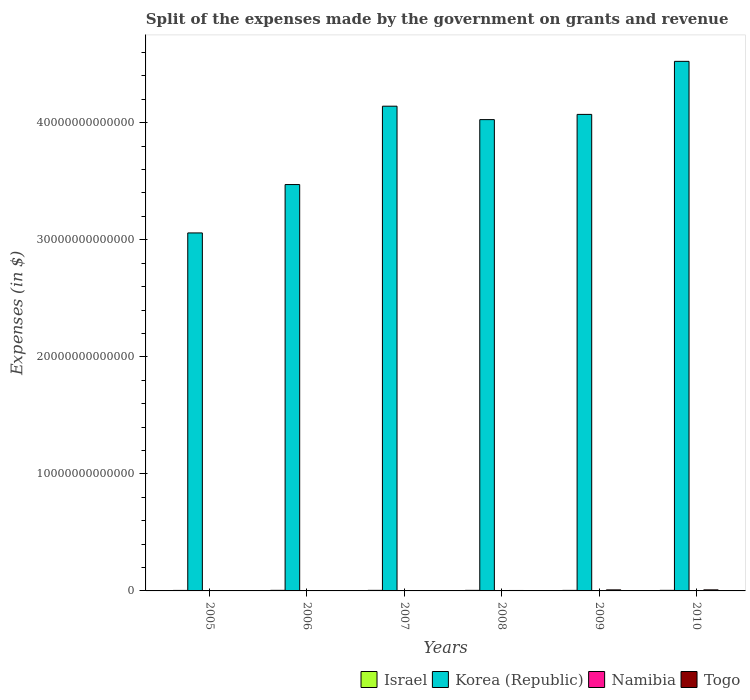How many different coloured bars are there?
Your answer should be compact. 4. Are the number of bars on each tick of the X-axis equal?
Give a very brief answer. Yes. How many bars are there on the 6th tick from the left?
Provide a succinct answer. 4. How many bars are there on the 1st tick from the right?
Your answer should be compact. 4. What is the label of the 1st group of bars from the left?
Provide a succinct answer. 2005. In how many cases, is the number of bars for a given year not equal to the number of legend labels?
Offer a terse response. 0. What is the expenses made by the government on grants and revenue in Korea (Republic) in 2007?
Your answer should be compact. 4.14e+13. Across all years, what is the maximum expenses made by the government on grants and revenue in Togo?
Provide a succinct answer. 8.96e+1. Across all years, what is the minimum expenses made by the government on grants and revenue in Namibia?
Keep it short and to the point. 1.10e+09. What is the total expenses made by the government on grants and revenue in Togo in the graph?
Offer a very short reply. 2.82e+11. What is the difference between the expenses made by the government on grants and revenue in Korea (Republic) in 2006 and that in 2007?
Provide a short and direct response. -6.70e+12. What is the difference between the expenses made by the government on grants and revenue in Namibia in 2010 and the expenses made by the government on grants and revenue in Korea (Republic) in 2009?
Offer a very short reply. -4.07e+13. What is the average expenses made by the government on grants and revenue in Israel per year?
Your response must be concise. 4.79e+1. In the year 2008, what is the difference between the expenses made by the government on grants and revenue in Togo and expenses made by the government on grants and revenue in Korea (Republic)?
Ensure brevity in your answer.  -4.02e+13. In how many years, is the expenses made by the government on grants and revenue in Korea (Republic) greater than 20000000000000 $?
Give a very brief answer. 6. What is the ratio of the expenses made by the government on grants and revenue in Korea (Republic) in 2008 to that in 2010?
Keep it short and to the point. 0.89. What is the difference between the highest and the second highest expenses made by the government on grants and revenue in Togo?
Provide a short and direct response. 6.60e+08. What is the difference between the highest and the lowest expenses made by the government on grants and revenue in Korea (Republic)?
Give a very brief answer. 1.47e+13. Is the sum of the expenses made by the government on grants and revenue in Togo in 2005 and 2006 greater than the maximum expenses made by the government on grants and revenue in Israel across all years?
Your response must be concise. No. Is it the case that in every year, the sum of the expenses made by the government on grants and revenue in Korea (Republic) and expenses made by the government on grants and revenue in Israel is greater than the sum of expenses made by the government on grants and revenue in Namibia and expenses made by the government on grants and revenue in Togo?
Offer a very short reply. No. What does the 1st bar from the right in 2010 represents?
Ensure brevity in your answer.  Togo. Are all the bars in the graph horizontal?
Provide a succinct answer. No. What is the difference between two consecutive major ticks on the Y-axis?
Ensure brevity in your answer.  1.00e+13. Does the graph contain any zero values?
Keep it short and to the point. No. Does the graph contain grids?
Your response must be concise. No. Where does the legend appear in the graph?
Ensure brevity in your answer.  Bottom right. How many legend labels are there?
Your answer should be compact. 4. What is the title of the graph?
Provide a succinct answer. Split of the expenses made by the government on grants and revenue. What is the label or title of the Y-axis?
Your answer should be compact. Expenses (in $). What is the Expenses (in $) of Israel in 2005?
Provide a succinct answer. 4.33e+1. What is the Expenses (in $) in Korea (Republic) in 2005?
Provide a short and direct response. 3.06e+13. What is the Expenses (in $) in Namibia in 2005?
Make the answer very short. 1.10e+09. What is the Expenses (in $) of Togo in 2005?
Give a very brief answer. 8.55e+09. What is the Expenses (in $) of Israel in 2006?
Your response must be concise. 5.00e+1. What is the Expenses (in $) of Korea (Republic) in 2006?
Keep it short and to the point. 3.47e+13. What is the Expenses (in $) in Namibia in 2006?
Give a very brief answer. 1.75e+09. What is the Expenses (in $) of Togo in 2006?
Provide a succinct answer. 2.87e+1. What is the Expenses (in $) in Israel in 2007?
Offer a terse response. 4.86e+1. What is the Expenses (in $) in Korea (Republic) in 2007?
Provide a succinct answer. 4.14e+13. What is the Expenses (in $) in Namibia in 2007?
Keep it short and to the point. 1.30e+09. What is the Expenses (in $) of Togo in 2007?
Offer a very short reply. 2.78e+1. What is the Expenses (in $) in Israel in 2008?
Ensure brevity in your answer.  4.93e+1. What is the Expenses (in $) in Korea (Republic) in 2008?
Offer a very short reply. 4.03e+13. What is the Expenses (in $) in Namibia in 2008?
Provide a succinct answer. 2.17e+09. What is the Expenses (in $) in Togo in 2008?
Provide a succinct answer. 3.87e+1. What is the Expenses (in $) in Israel in 2009?
Your answer should be compact. 4.61e+1. What is the Expenses (in $) of Korea (Republic) in 2009?
Offer a very short reply. 4.07e+13. What is the Expenses (in $) of Namibia in 2009?
Ensure brevity in your answer.  1.77e+09. What is the Expenses (in $) in Togo in 2009?
Provide a short and direct response. 8.90e+1. What is the Expenses (in $) of Israel in 2010?
Offer a terse response. 5.00e+1. What is the Expenses (in $) of Korea (Republic) in 2010?
Your answer should be compact. 4.52e+13. What is the Expenses (in $) of Namibia in 2010?
Ensure brevity in your answer.  1.72e+09. What is the Expenses (in $) of Togo in 2010?
Offer a terse response. 8.96e+1. Across all years, what is the maximum Expenses (in $) of Israel?
Make the answer very short. 5.00e+1. Across all years, what is the maximum Expenses (in $) of Korea (Republic)?
Your response must be concise. 4.52e+13. Across all years, what is the maximum Expenses (in $) of Namibia?
Offer a terse response. 2.17e+09. Across all years, what is the maximum Expenses (in $) of Togo?
Offer a terse response. 8.96e+1. Across all years, what is the minimum Expenses (in $) of Israel?
Provide a succinct answer. 4.33e+1. Across all years, what is the minimum Expenses (in $) in Korea (Republic)?
Offer a very short reply. 3.06e+13. Across all years, what is the minimum Expenses (in $) of Namibia?
Ensure brevity in your answer.  1.10e+09. Across all years, what is the minimum Expenses (in $) in Togo?
Your response must be concise. 8.55e+09. What is the total Expenses (in $) of Israel in the graph?
Your response must be concise. 2.87e+11. What is the total Expenses (in $) of Korea (Republic) in the graph?
Keep it short and to the point. 2.33e+14. What is the total Expenses (in $) of Namibia in the graph?
Offer a very short reply. 9.82e+09. What is the total Expenses (in $) in Togo in the graph?
Make the answer very short. 2.82e+11. What is the difference between the Expenses (in $) in Israel in 2005 and that in 2006?
Ensure brevity in your answer.  -6.74e+09. What is the difference between the Expenses (in $) of Korea (Republic) in 2005 and that in 2006?
Give a very brief answer. -4.13e+12. What is the difference between the Expenses (in $) in Namibia in 2005 and that in 2006?
Provide a short and direct response. -6.48e+08. What is the difference between the Expenses (in $) of Togo in 2005 and that in 2006?
Ensure brevity in your answer.  -2.01e+1. What is the difference between the Expenses (in $) of Israel in 2005 and that in 2007?
Give a very brief answer. -5.36e+09. What is the difference between the Expenses (in $) of Korea (Republic) in 2005 and that in 2007?
Offer a very short reply. -1.08e+13. What is the difference between the Expenses (in $) in Namibia in 2005 and that in 2007?
Offer a very short reply. -2.07e+08. What is the difference between the Expenses (in $) in Togo in 2005 and that in 2007?
Ensure brevity in your answer.  -1.93e+1. What is the difference between the Expenses (in $) in Israel in 2005 and that in 2008?
Make the answer very short. -6.08e+09. What is the difference between the Expenses (in $) in Korea (Republic) in 2005 and that in 2008?
Keep it short and to the point. -9.68e+12. What is the difference between the Expenses (in $) in Namibia in 2005 and that in 2008?
Your answer should be very brief. -1.08e+09. What is the difference between the Expenses (in $) of Togo in 2005 and that in 2008?
Provide a short and direct response. -3.01e+1. What is the difference between the Expenses (in $) of Israel in 2005 and that in 2009?
Offer a terse response. -2.79e+09. What is the difference between the Expenses (in $) of Korea (Republic) in 2005 and that in 2009?
Your response must be concise. -1.01e+13. What is the difference between the Expenses (in $) of Namibia in 2005 and that in 2009?
Your answer should be very brief. -6.76e+08. What is the difference between the Expenses (in $) in Togo in 2005 and that in 2009?
Give a very brief answer. -8.04e+1. What is the difference between the Expenses (in $) of Israel in 2005 and that in 2010?
Your answer should be very brief. -6.73e+09. What is the difference between the Expenses (in $) of Korea (Republic) in 2005 and that in 2010?
Offer a terse response. -1.47e+13. What is the difference between the Expenses (in $) in Namibia in 2005 and that in 2010?
Keep it short and to the point. -6.27e+08. What is the difference between the Expenses (in $) in Togo in 2005 and that in 2010?
Provide a short and direct response. -8.11e+1. What is the difference between the Expenses (in $) of Israel in 2006 and that in 2007?
Give a very brief answer. 1.39e+09. What is the difference between the Expenses (in $) in Korea (Republic) in 2006 and that in 2007?
Provide a short and direct response. -6.70e+12. What is the difference between the Expenses (in $) of Namibia in 2006 and that in 2007?
Ensure brevity in your answer.  4.41e+08. What is the difference between the Expenses (in $) in Togo in 2006 and that in 2007?
Your response must be concise. 8.62e+08. What is the difference between the Expenses (in $) in Israel in 2006 and that in 2008?
Your answer should be very brief. 6.60e+08. What is the difference between the Expenses (in $) in Korea (Republic) in 2006 and that in 2008?
Make the answer very short. -5.55e+12. What is the difference between the Expenses (in $) in Namibia in 2006 and that in 2008?
Make the answer very short. -4.29e+08. What is the difference between the Expenses (in $) in Togo in 2006 and that in 2008?
Your answer should be very brief. -9.99e+09. What is the difference between the Expenses (in $) of Israel in 2006 and that in 2009?
Offer a terse response. 3.95e+09. What is the difference between the Expenses (in $) in Korea (Republic) in 2006 and that in 2009?
Offer a very short reply. -5.99e+12. What is the difference between the Expenses (in $) in Namibia in 2006 and that in 2009?
Keep it short and to the point. -2.82e+07. What is the difference between the Expenses (in $) in Togo in 2006 and that in 2009?
Your answer should be very brief. -6.03e+1. What is the difference between the Expenses (in $) in Israel in 2006 and that in 2010?
Offer a terse response. 1.64e+07. What is the difference between the Expenses (in $) of Korea (Republic) in 2006 and that in 2010?
Keep it short and to the point. -1.05e+13. What is the difference between the Expenses (in $) in Namibia in 2006 and that in 2010?
Offer a very short reply. 2.13e+07. What is the difference between the Expenses (in $) of Togo in 2006 and that in 2010?
Keep it short and to the point. -6.09e+1. What is the difference between the Expenses (in $) in Israel in 2007 and that in 2008?
Your answer should be compact. -7.26e+08. What is the difference between the Expenses (in $) in Korea (Republic) in 2007 and that in 2008?
Provide a short and direct response. 1.15e+12. What is the difference between the Expenses (in $) of Namibia in 2007 and that in 2008?
Give a very brief answer. -8.70e+08. What is the difference between the Expenses (in $) in Togo in 2007 and that in 2008?
Keep it short and to the point. -1.08e+1. What is the difference between the Expenses (in $) of Israel in 2007 and that in 2009?
Ensure brevity in your answer.  2.57e+09. What is the difference between the Expenses (in $) of Korea (Republic) in 2007 and that in 2009?
Provide a succinct answer. 7.01e+11. What is the difference between the Expenses (in $) in Namibia in 2007 and that in 2009?
Your answer should be compact. -4.69e+08. What is the difference between the Expenses (in $) in Togo in 2007 and that in 2009?
Keep it short and to the point. -6.11e+1. What is the difference between the Expenses (in $) in Israel in 2007 and that in 2010?
Make the answer very short. -1.37e+09. What is the difference between the Expenses (in $) of Korea (Republic) in 2007 and that in 2010?
Ensure brevity in your answer.  -3.83e+12. What is the difference between the Expenses (in $) in Namibia in 2007 and that in 2010?
Keep it short and to the point. -4.20e+08. What is the difference between the Expenses (in $) in Togo in 2007 and that in 2010?
Your answer should be very brief. -6.18e+1. What is the difference between the Expenses (in $) of Israel in 2008 and that in 2009?
Provide a succinct answer. 3.29e+09. What is the difference between the Expenses (in $) of Korea (Republic) in 2008 and that in 2009?
Your answer should be very brief. -4.46e+11. What is the difference between the Expenses (in $) in Namibia in 2008 and that in 2009?
Ensure brevity in your answer.  4.01e+08. What is the difference between the Expenses (in $) of Togo in 2008 and that in 2009?
Your answer should be compact. -5.03e+1. What is the difference between the Expenses (in $) of Israel in 2008 and that in 2010?
Give a very brief answer. -6.44e+08. What is the difference between the Expenses (in $) in Korea (Republic) in 2008 and that in 2010?
Keep it short and to the point. -4.98e+12. What is the difference between the Expenses (in $) of Namibia in 2008 and that in 2010?
Offer a very short reply. 4.50e+08. What is the difference between the Expenses (in $) of Togo in 2008 and that in 2010?
Offer a very short reply. -5.10e+1. What is the difference between the Expenses (in $) of Israel in 2009 and that in 2010?
Provide a short and direct response. -3.93e+09. What is the difference between the Expenses (in $) of Korea (Republic) in 2009 and that in 2010?
Give a very brief answer. -4.53e+12. What is the difference between the Expenses (in $) in Namibia in 2009 and that in 2010?
Provide a succinct answer. 4.94e+07. What is the difference between the Expenses (in $) in Togo in 2009 and that in 2010?
Give a very brief answer. -6.60e+08. What is the difference between the Expenses (in $) of Israel in 2005 and the Expenses (in $) of Korea (Republic) in 2006?
Give a very brief answer. -3.47e+13. What is the difference between the Expenses (in $) in Israel in 2005 and the Expenses (in $) in Namibia in 2006?
Give a very brief answer. 4.15e+1. What is the difference between the Expenses (in $) of Israel in 2005 and the Expenses (in $) of Togo in 2006?
Make the answer very short. 1.46e+1. What is the difference between the Expenses (in $) in Korea (Republic) in 2005 and the Expenses (in $) in Namibia in 2006?
Make the answer very short. 3.06e+13. What is the difference between the Expenses (in $) in Korea (Republic) in 2005 and the Expenses (in $) in Togo in 2006?
Give a very brief answer. 3.06e+13. What is the difference between the Expenses (in $) of Namibia in 2005 and the Expenses (in $) of Togo in 2006?
Provide a short and direct response. -2.76e+1. What is the difference between the Expenses (in $) of Israel in 2005 and the Expenses (in $) of Korea (Republic) in 2007?
Offer a very short reply. -4.14e+13. What is the difference between the Expenses (in $) in Israel in 2005 and the Expenses (in $) in Namibia in 2007?
Ensure brevity in your answer.  4.20e+1. What is the difference between the Expenses (in $) in Israel in 2005 and the Expenses (in $) in Togo in 2007?
Your response must be concise. 1.55e+1. What is the difference between the Expenses (in $) of Korea (Republic) in 2005 and the Expenses (in $) of Namibia in 2007?
Offer a very short reply. 3.06e+13. What is the difference between the Expenses (in $) of Korea (Republic) in 2005 and the Expenses (in $) of Togo in 2007?
Provide a short and direct response. 3.06e+13. What is the difference between the Expenses (in $) in Namibia in 2005 and the Expenses (in $) in Togo in 2007?
Your answer should be compact. -2.67e+1. What is the difference between the Expenses (in $) of Israel in 2005 and the Expenses (in $) of Korea (Republic) in 2008?
Your answer should be very brief. -4.02e+13. What is the difference between the Expenses (in $) in Israel in 2005 and the Expenses (in $) in Namibia in 2008?
Your answer should be compact. 4.11e+1. What is the difference between the Expenses (in $) in Israel in 2005 and the Expenses (in $) in Togo in 2008?
Provide a succinct answer. 4.60e+09. What is the difference between the Expenses (in $) of Korea (Republic) in 2005 and the Expenses (in $) of Namibia in 2008?
Ensure brevity in your answer.  3.06e+13. What is the difference between the Expenses (in $) in Korea (Republic) in 2005 and the Expenses (in $) in Togo in 2008?
Ensure brevity in your answer.  3.05e+13. What is the difference between the Expenses (in $) of Namibia in 2005 and the Expenses (in $) of Togo in 2008?
Ensure brevity in your answer.  -3.76e+1. What is the difference between the Expenses (in $) of Israel in 2005 and the Expenses (in $) of Korea (Republic) in 2009?
Offer a terse response. -4.07e+13. What is the difference between the Expenses (in $) in Israel in 2005 and the Expenses (in $) in Namibia in 2009?
Your response must be concise. 4.15e+1. What is the difference between the Expenses (in $) in Israel in 2005 and the Expenses (in $) in Togo in 2009?
Your response must be concise. -4.57e+1. What is the difference between the Expenses (in $) in Korea (Republic) in 2005 and the Expenses (in $) in Namibia in 2009?
Keep it short and to the point. 3.06e+13. What is the difference between the Expenses (in $) of Korea (Republic) in 2005 and the Expenses (in $) of Togo in 2009?
Your answer should be compact. 3.05e+13. What is the difference between the Expenses (in $) in Namibia in 2005 and the Expenses (in $) in Togo in 2009?
Provide a succinct answer. -8.79e+1. What is the difference between the Expenses (in $) of Israel in 2005 and the Expenses (in $) of Korea (Republic) in 2010?
Your answer should be very brief. -4.52e+13. What is the difference between the Expenses (in $) in Israel in 2005 and the Expenses (in $) in Namibia in 2010?
Your response must be concise. 4.15e+1. What is the difference between the Expenses (in $) in Israel in 2005 and the Expenses (in $) in Togo in 2010?
Your response must be concise. -4.64e+1. What is the difference between the Expenses (in $) of Korea (Republic) in 2005 and the Expenses (in $) of Namibia in 2010?
Make the answer very short. 3.06e+13. What is the difference between the Expenses (in $) of Korea (Republic) in 2005 and the Expenses (in $) of Togo in 2010?
Make the answer very short. 3.05e+13. What is the difference between the Expenses (in $) in Namibia in 2005 and the Expenses (in $) in Togo in 2010?
Ensure brevity in your answer.  -8.85e+1. What is the difference between the Expenses (in $) in Israel in 2006 and the Expenses (in $) in Korea (Republic) in 2007?
Offer a terse response. -4.14e+13. What is the difference between the Expenses (in $) of Israel in 2006 and the Expenses (in $) of Namibia in 2007?
Your answer should be very brief. 4.87e+1. What is the difference between the Expenses (in $) in Israel in 2006 and the Expenses (in $) in Togo in 2007?
Your response must be concise. 2.22e+1. What is the difference between the Expenses (in $) of Korea (Republic) in 2006 and the Expenses (in $) of Namibia in 2007?
Make the answer very short. 3.47e+13. What is the difference between the Expenses (in $) of Korea (Republic) in 2006 and the Expenses (in $) of Togo in 2007?
Keep it short and to the point. 3.47e+13. What is the difference between the Expenses (in $) in Namibia in 2006 and the Expenses (in $) in Togo in 2007?
Keep it short and to the point. -2.61e+1. What is the difference between the Expenses (in $) in Israel in 2006 and the Expenses (in $) in Korea (Republic) in 2008?
Your answer should be compact. -4.02e+13. What is the difference between the Expenses (in $) of Israel in 2006 and the Expenses (in $) of Namibia in 2008?
Provide a short and direct response. 4.78e+1. What is the difference between the Expenses (in $) of Israel in 2006 and the Expenses (in $) of Togo in 2008?
Offer a very short reply. 1.13e+1. What is the difference between the Expenses (in $) in Korea (Republic) in 2006 and the Expenses (in $) in Namibia in 2008?
Provide a short and direct response. 3.47e+13. What is the difference between the Expenses (in $) in Korea (Republic) in 2006 and the Expenses (in $) in Togo in 2008?
Offer a very short reply. 3.47e+13. What is the difference between the Expenses (in $) of Namibia in 2006 and the Expenses (in $) of Togo in 2008?
Ensure brevity in your answer.  -3.69e+1. What is the difference between the Expenses (in $) in Israel in 2006 and the Expenses (in $) in Korea (Republic) in 2009?
Ensure brevity in your answer.  -4.07e+13. What is the difference between the Expenses (in $) of Israel in 2006 and the Expenses (in $) of Namibia in 2009?
Keep it short and to the point. 4.82e+1. What is the difference between the Expenses (in $) of Israel in 2006 and the Expenses (in $) of Togo in 2009?
Make the answer very short. -3.89e+1. What is the difference between the Expenses (in $) of Korea (Republic) in 2006 and the Expenses (in $) of Namibia in 2009?
Your response must be concise. 3.47e+13. What is the difference between the Expenses (in $) of Korea (Republic) in 2006 and the Expenses (in $) of Togo in 2009?
Your answer should be compact. 3.46e+13. What is the difference between the Expenses (in $) of Namibia in 2006 and the Expenses (in $) of Togo in 2009?
Provide a short and direct response. -8.72e+1. What is the difference between the Expenses (in $) in Israel in 2006 and the Expenses (in $) in Korea (Republic) in 2010?
Provide a succinct answer. -4.52e+13. What is the difference between the Expenses (in $) of Israel in 2006 and the Expenses (in $) of Namibia in 2010?
Provide a succinct answer. 4.83e+1. What is the difference between the Expenses (in $) in Israel in 2006 and the Expenses (in $) in Togo in 2010?
Your response must be concise. -3.96e+1. What is the difference between the Expenses (in $) in Korea (Republic) in 2006 and the Expenses (in $) in Namibia in 2010?
Make the answer very short. 3.47e+13. What is the difference between the Expenses (in $) in Korea (Republic) in 2006 and the Expenses (in $) in Togo in 2010?
Offer a terse response. 3.46e+13. What is the difference between the Expenses (in $) in Namibia in 2006 and the Expenses (in $) in Togo in 2010?
Provide a short and direct response. -8.79e+1. What is the difference between the Expenses (in $) in Israel in 2007 and the Expenses (in $) in Korea (Republic) in 2008?
Give a very brief answer. -4.02e+13. What is the difference between the Expenses (in $) of Israel in 2007 and the Expenses (in $) of Namibia in 2008?
Give a very brief answer. 4.64e+1. What is the difference between the Expenses (in $) in Israel in 2007 and the Expenses (in $) in Togo in 2008?
Make the answer very short. 9.96e+09. What is the difference between the Expenses (in $) in Korea (Republic) in 2007 and the Expenses (in $) in Namibia in 2008?
Your answer should be compact. 4.14e+13. What is the difference between the Expenses (in $) in Korea (Republic) in 2007 and the Expenses (in $) in Togo in 2008?
Keep it short and to the point. 4.14e+13. What is the difference between the Expenses (in $) in Namibia in 2007 and the Expenses (in $) in Togo in 2008?
Make the answer very short. -3.74e+1. What is the difference between the Expenses (in $) in Israel in 2007 and the Expenses (in $) in Korea (Republic) in 2009?
Ensure brevity in your answer.  -4.07e+13. What is the difference between the Expenses (in $) in Israel in 2007 and the Expenses (in $) in Namibia in 2009?
Give a very brief answer. 4.68e+1. What is the difference between the Expenses (in $) of Israel in 2007 and the Expenses (in $) of Togo in 2009?
Your response must be concise. -4.03e+1. What is the difference between the Expenses (in $) in Korea (Republic) in 2007 and the Expenses (in $) in Namibia in 2009?
Offer a terse response. 4.14e+13. What is the difference between the Expenses (in $) in Korea (Republic) in 2007 and the Expenses (in $) in Togo in 2009?
Your answer should be compact. 4.13e+13. What is the difference between the Expenses (in $) of Namibia in 2007 and the Expenses (in $) of Togo in 2009?
Give a very brief answer. -8.76e+1. What is the difference between the Expenses (in $) of Israel in 2007 and the Expenses (in $) of Korea (Republic) in 2010?
Keep it short and to the point. -4.52e+13. What is the difference between the Expenses (in $) in Israel in 2007 and the Expenses (in $) in Namibia in 2010?
Keep it short and to the point. 4.69e+1. What is the difference between the Expenses (in $) in Israel in 2007 and the Expenses (in $) in Togo in 2010?
Offer a very short reply. -4.10e+1. What is the difference between the Expenses (in $) of Korea (Republic) in 2007 and the Expenses (in $) of Namibia in 2010?
Your answer should be compact. 4.14e+13. What is the difference between the Expenses (in $) of Korea (Republic) in 2007 and the Expenses (in $) of Togo in 2010?
Offer a very short reply. 4.13e+13. What is the difference between the Expenses (in $) of Namibia in 2007 and the Expenses (in $) of Togo in 2010?
Offer a very short reply. -8.83e+1. What is the difference between the Expenses (in $) in Israel in 2008 and the Expenses (in $) in Korea (Republic) in 2009?
Your answer should be very brief. -4.07e+13. What is the difference between the Expenses (in $) in Israel in 2008 and the Expenses (in $) in Namibia in 2009?
Your answer should be very brief. 4.76e+1. What is the difference between the Expenses (in $) of Israel in 2008 and the Expenses (in $) of Togo in 2009?
Offer a terse response. -3.96e+1. What is the difference between the Expenses (in $) in Korea (Republic) in 2008 and the Expenses (in $) in Namibia in 2009?
Make the answer very short. 4.03e+13. What is the difference between the Expenses (in $) of Korea (Republic) in 2008 and the Expenses (in $) of Togo in 2009?
Give a very brief answer. 4.02e+13. What is the difference between the Expenses (in $) in Namibia in 2008 and the Expenses (in $) in Togo in 2009?
Offer a very short reply. -8.68e+1. What is the difference between the Expenses (in $) in Israel in 2008 and the Expenses (in $) in Korea (Republic) in 2010?
Offer a terse response. -4.52e+13. What is the difference between the Expenses (in $) in Israel in 2008 and the Expenses (in $) in Namibia in 2010?
Your response must be concise. 4.76e+1. What is the difference between the Expenses (in $) in Israel in 2008 and the Expenses (in $) in Togo in 2010?
Give a very brief answer. -4.03e+1. What is the difference between the Expenses (in $) in Korea (Republic) in 2008 and the Expenses (in $) in Namibia in 2010?
Your answer should be compact. 4.03e+13. What is the difference between the Expenses (in $) in Korea (Republic) in 2008 and the Expenses (in $) in Togo in 2010?
Your response must be concise. 4.02e+13. What is the difference between the Expenses (in $) of Namibia in 2008 and the Expenses (in $) of Togo in 2010?
Provide a succinct answer. -8.74e+1. What is the difference between the Expenses (in $) in Israel in 2009 and the Expenses (in $) in Korea (Republic) in 2010?
Offer a very short reply. -4.52e+13. What is the difference between the Expenses (in $) in Israel in 2009 and the Expenses (in $) in Namibia in 2010?
Your answer should be very brief. 4.43e+1. What is the difference between the Expenses (in $) of Israel in 2009 and the Expenses (in $) of Togo in 2010?
Give a very brief answer. -4.36e+1. What is the difference between the Expenses (in $) of Korea (Republic) in 2009 and the Expenses (in $) of Namibia in 2010?
Ensure brevity in your answer.  4.07e+13. What is the difference between the Expenses (in $) of Korea (Republic) in 2009 and the Expenses (in $) of Togo in 2010?
Make the answer very short. 4.06e+13. What is the difference between the Expenses (in $) in Namibia in 2009 and the Expenses (in $) in Togo in 2010?
Your response must be concise. -8.78e+1. What is the average Expenses (in $) of Israel per year?
Offer a terse response. 4.79e+1. What is the average Expenses (in $) of Korea (Republic) per year?
Offer a terse response. 3.88e+13. What is the average Expenses (in $) of Namibia per year?
Provide a succinct answer. 1.64e+09. What is the average Expenses (in $) of Togo per year?
Offer a terse response. 4.70e+1. In the year 2005, what is the difference between the Expenses (in $) in Israel and Expenses (in $) in Korea (Republic)?
Make the answer very short. -3.05e+13. In the year 2005, what is the difference between the Expenses (in $) in Israel and Expenses (in $) in Namibia?
Offer a terse response. 4.22e+1. In the year 2005, what is the difference between the Expenses (in $) of Israel and Expenses (in $) of Togo?
Your answer should be very brief. 3.47e+1. In the year 2005, what is the difference between the Expenses (in $) in Korea (Republic) and Expenses (in $) in Namibia?
Offer a very short reply. 3.06e+13. In the year 2005, what is the difference between the Expenses (in $) of Korea (Republic) and Expenses (in $) of Togo?
Offer a terse response. 3.06e+13. In the year 2005, what is the difference between the Expenses (in $) in Namibia and Expenses (in $) in Togo?
Keep it short and to the point. -7.45e+09. In the year 2006, what is the difference between the Expenses (in $) of Israel and Expenses (in $) of Korea (Republic)?
Offer a very short reply. -3.47e+13. In the year 2006, what is the difference between the Expenses (in $) of Israel and Expenses (in $) of Namibia?
Your answer should be very brief. 4.83e+1. In the year 2006, what is the difference between the Expenses (in $) in Israel and Expenses (in $) in Togo?
Offer a very short reply. 2.13e+1. In the year 2006, what is the difference between the Expenses (in $) in Korea (Republic) and Expenses (in $) in Namibia?
Your answer should be very brief. 3.47e+13. In the year 2006, what is the difference between the Expenses (in $) in Korea (Republic) and Expenses (in $) in Togo?
Your response must be concise. 3.47e+13. In the year 2006, what is the difference between the Expenses (in $) in Namibia and Expenses (in $) in Togo?
Keep it short and to the point. -2.69e+1. In the year 2007, what is the difference between the Expenses (in $) of Israel and Expenses (in $) of Korea (Republic)?
Offer a very short reply. -4.14e+13. In the year 2007, what is the difference between the Expenses (in $) in Israel and Expenses (in $) in Namibia?
Keep it short and to the point. 4.73e+1. In the year 2007, what is the difference between the Expenses (in $) of Israel and Expenses (in $) of Togo?
Provide a short and direct response. 2.08e+1. In the year 2007, what is the difference between the Expenses (in $) in Korea (Republic) and Expenses (in $) in Namibia?
Provide a short and direct response. 4.14e+13. In the year 2007, what is the difference between the Expenses (in $) of Korea (Republic) and Expenses (in $) of Togo?
Offer a very short reply. 4.14e+13. In the year 2007, what is the difference between the Expenses (in $) of Namibia and Expenses (in $) of Togo?
Make the answer very short. -2.65e+1. In the year 2008, what is the difference between the Expenses (in $) in Israel and Expenses (in $) in Korea (Republic)?
Offer a very short reply. -4.02e+13. In the year 2008, what is the difference between the Expenses (in $) in Israel and Expenses (in $) in Namibia?
Ensure brevity in your answer.  4.72e+1. In the year 2008, what is the difference between the Expenses (in $) of Israel and Expenses (in $) of Togo?
Your answer should be very brief. 1.07e+1. In the year 2008, what is the difference between the Expenses (in $) in Korea (Republic) and Expenses (in $) in Namibia?
Provide a succinct answer. 4.03e+13. In the year 2008, what is the difference between the Expenses (in $) of Korea (Republic) and Expenses (in $) of Togo?
Give a very brief answer. 4.02e+13. In the year 2008, what is the difference between the Expenses (in $) of Namibia and Expenses (in $) of Togo?
Your response must be concise. -3.65e+1. In the year 2009, what is the difference between the Expenses (in $) in Israel and Expenses (in $) in Korea (Republic)?
Offer a terse response. -4.07e+13. In the year 2009, what is the difference between the Expenses (in $) in Israel and Expenses (in $) in Namibia?
Your answer should be very brief. 4.43e+1. In the year 2009, what is the difference between the Expenses (in $) of Israel and Expenses (in $) of Togo?
Your response must be concise. -4.29e+1. In the year 2009, what is the difference between the Expenses (in $) in Korea (Republic) and Expenses (in $) in Namibia?
Provide a short and direct response. 4.07e+13. In the year 2009, what is the difference between the Expenses (in $) in Korea (Republic) and Expenses (in $) in Togo?
Make the answer very short. 4.06e+13. In the year 2009, what is the difference between the Expenses (in $) of Namibia and Expenses (in $) of Togo?
Your answer should be compact. -8.72e+1. In the year 2010, what is the difference between the Expenses (in $) in Israel and Expenses (in $) in Korea (Republic)?
Your response must be concise. -4.52e+13. In the year 2010, what is the difference between the Expenses (in $) in Israel and Expenses (in $) in Namibia?
Give a very brief answer. 4.83e+1. In the year 2010, what is the difference between the Expenses (in $) of Israel and Expenses (in $) of Togo?
Keep it short and to the point. -3.96e+1. In the year 2010, what is the difference between the Expenses (in $) in Korea (Republic) and Expenses (in $) in Namibia?
Your answer should be very brief. 4.52e+13. In the year 2010, what is the difference between the Expenses (in $) in Korea (Republic) and Expenses (in $) in Togo?
Provide a short and direct response. 4.52e+13. In the year 2010, what is the difference between the Expenses (in $) in Namibia and Expenses (in $) in Togo?
Make the answer very short. -8.79e+1. What is the ratio of the Expenses (in $) in Israel in 2005 to that in 2006?
Ensure brevity in your answer.  0.87. What is the ratio of the Expenses (in $) in Korea (Republic) in 2005 to that in 2006?
Keep it short and to the point. 0.88. What is the ratio of the Expenses (in $) in Namibia in 2005 to that in 2006?
Provide a short and direct response. 0.63. What is the ratio of the Expenses (in $) of Togo in 2005 to that in 2006?
Provide a succinct answer. 0.3. What is the ratio of the Expenses (in $) of Israel in 2005 to that in 2007?
Give a very brief answer. 0.89. What is the ratio of the Expenses (in $) in Korea (Republic) in 2005 to that in 2007?
Ensure brevity in your answer.  0.74. What is the ratio of the Expenses (in $) in Namibia in 2005 to that in 2007?
Offer a terse response. 0.84. What is the ratio of the Expenses (in $) of Togo in 2005 to that in 2007?
Your response must be concise. 0.31. What is the ratio of the Expenses (in $) in Israel in 2005 to that in 2008?
Provide a succinct answer. 0.88. What is the ratio of the Expenses (in $) of Korea (Republic) in 2005 to that in 2008?
Your answer should be very brief. 0.76. What is the ratio of the Expenses (in $) of Namibia in 2005 to that in 2008?
Make the answer very short. 0.5. What is the ratio of the Expenses (in $) of Togo in 2005 to that in 2008?
Offer a terse response. 0.22. What is the ratio of the Expenses (in $) in Israel in 2005 to that in 2009?
Provide a short and direct response. 0.94. What is the ratio of the Expenses (in $) in Korea (Republic) in 2005 to that in 2009?
Keep it short and to the point. 0.75. What is the ratio of the Expenses (in $) in Namibia in 2005 to that in 2009?
Give a very brief answer. 0.62. What is the ratio of the Expenses (in $) of Togo in 2005 to that in 2009?
Give a very brief answer. 0.1. What is the ratio of the Expenses (in $) in Israel in 2005 to that in 2010?
Ensure brevity in your answer.  0.87. What is the ratio of the Expenses (in $) in Korea (Republic) in 2005 to that in 2010?
Offer a very short reply. 0.68. What is the ratio of the Expenses (in $) in Namibia in 2005 to that in 2010?
Keep it short and to the point. 0.64. What is the ratio of the Expenses (in $) in Togo in 2005 to that in 2010?
Give a very brief answer. 0.1. What is the ratio of the Expenses (in $) in Israel in 2006 to that in 2007?
Your answer should be very brief. 1.03. What is the ratio of the Expenses (in $) of Korea (Republic) in 2006 to that in 2007?
Your response must be concise. 0.84. What is the ratio of the Expenses (in $) of Namibia in 2006 to that in 2007?
Your answer should be very brief. 1.34. What is the ratio of the Expenses (in $) in Togo in 2006 to that in 2007?
Offer a very short reply. 1.03. What is the ratio of the Expenses (in $) of Israel in 2006 to that in 2008?
Your response must be concise. 1.01. What is the ratio of the Expenses (in $) of Korea (Republic) in 2006 to that in 2008?
Make the answer very short. 0.86. What is the ratio of the Expenses (in $) in Namibia in 2006 to that in 2008?
Ensure brevity in your answer.  0.8. What is the ratio of the Expenses (in $) in Togo in 2006 to that in 2008?
Provide a short and direct response. 0.74. What is the ratio of the Expenses (in $) in Israel in 2006 to that in 2009?
Make the answer very short. 1.09. What is the ratio of the Expenses (in $) of Korea (Republic) in 2006 to that in 2009?
Your answer should be compact. 0.85. What is the ratio of the Expenses (in $) in Namibia in 2006 to that in 2009?
Give a very brief answer. 0.98. What is the ratio of the Expenses (in $) of Togo in 2006 to that in 2009?
Keep it short and to the point. 0.32. What is the ratio of the Expenses (in $) in Korea (Republic) in 2006 to that in 2010?
Your answer should be very brief. 0.77. What is the ratio of the Expenses (in $) in Namibia in 2006 to that in 2010?
Keep it short and to the point. 1.01. What is the ratio of the Expenses (in $) in Togo in 2006 to that in 2010?
Offer a very short reply. 0.32. What is the ratio of the Expenses (in $) of Korea (Republic) in 2007 to that in 2008?
Keep it short and to the point. 1.03. What is the ratio of the Expenses (in $) of Namibia in 2007 to that in 2008?
Keep it short and to the point. 0.6. What is the ratio of the Expenses (in $) in Togo in 2007 to that in 2008?
Provide a succinct answer. 0.72. What is the ratio of the Expenses (in $) in Israel in 2007 to that in 2009?
Your response must be concise. 1.06. What is the ratio of the Expenses (in $) in Korea (Republic) in 2007 to that in 2009?
Provide a short and direct response. 1.02. What is the ratio of the Expenses (in $) in Namibia in 2007 to that in 2009?
Your answer should be very brief. 0.74. What is the ratio of the Expenses (in $) in Togo in 2007 to that in 2009?
Give a very brief answer. 0.31. What is the ratio of the Expenses (in $) of Israel in 2007 to that in 2010?
Your response must be concise. 0.97. What is the ratio of the Expenses (in $) of Korea (Republic) in 2007 to that in 2010?
Ensure brevity in your answer.  0.92. What is the ratio of the Expenses (in $) of Namibia in 2007 to that in 2010?
Make the answer very short. 0.76. What is the ratio of the Expenses (in $) in Togo in 2007 to that in 2010?
Offer a very short reply. 0.31. What is the ratio of the Expenses (in $) in Israel in 2008 to that in 2009?
Provide a short and direct response. 1.07. What is the ratio of the Expenses (in $) in Namibia in 2008 to that in 2009?
Provide a short and direct response. 1.23. What is the ratio of the Expenses (in $) in Togo in 2008 to that in 2009?
Your response must be concise. 0.43. What is the ratio of the Expenses (in $) in Israel in 2008 to that in 2010?
Offer a very short reply. 0.99. What is the ratio of the Expenses (in $) of Korea (Republic) in 2008 to that in 2010?
Give a very brief answer. 0.89. What is the ratio of the Expenses (in $) of Namibia in 2008 to that in 2010?
Your response must be concise. 1.26. What is the ratio of the Expenses (in $) of Togo in 2008 to that in 2010?
Ensure brevity in your answer.  0.43. What is the ratio of the Expenses (in $) of Israel in 2009 to that in 2010?
Provide a succinct answer. 0.92. What is the ratio of the Expenses (in $) in Korea (Republic) in 2009 to that in 2010?
Make the answer very short. 0.9. What is the ratio of the Expenses (in $) of Namibia in 2009 to that in 2010?
Provide a short and direct response. 1.03. What is the ratio of the Expenses (in $) of Togo in 2009 to that in 2010?
Your answer should be very brief. 0.99. What is the difference between the highest and the second highest Expenses (in $) in Israel?
Offer a very short reply. 1.64e+07. What is the difference between the highest and the second highest Expenses (in $) in Korea (Republic)?
Offer a very short reply. 3.83e+12. What is the difference between the highest and the second highest Expenses (in $) in Namibia?
Your answer should be compact. 4.01e+08. What is the difference between the highest and the second highest Expenses (in $) of Togo?
Your response must be concise. 6.60e+08. What is the difference between the highest and the lowest Expenses (in $) of Israel?
Provide a short and direct response. 6.74e+09. What is the difference between the highest and the lowest Expenses (in $) of Korea (Republic)?
Your answer should be very brief. 1.47e+13. What is the difference between the highest and the lowest Expenses (in $) in Namibia?
Offer a very short reply. 1.08e+09. What is the difference between the highest and the lowest Expenses (in $) in Togo?
Your answer should be very brief. 8.11e+1. 